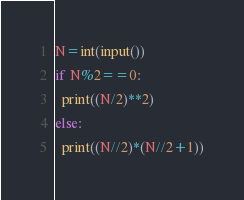<code> <loc_0><loc_0><loc_500><loc_500><_Python_>N=int(input())
if N%2==0:
  print((N/2)**2)
else:
  print((N//2)*(N//2+1))</code> 